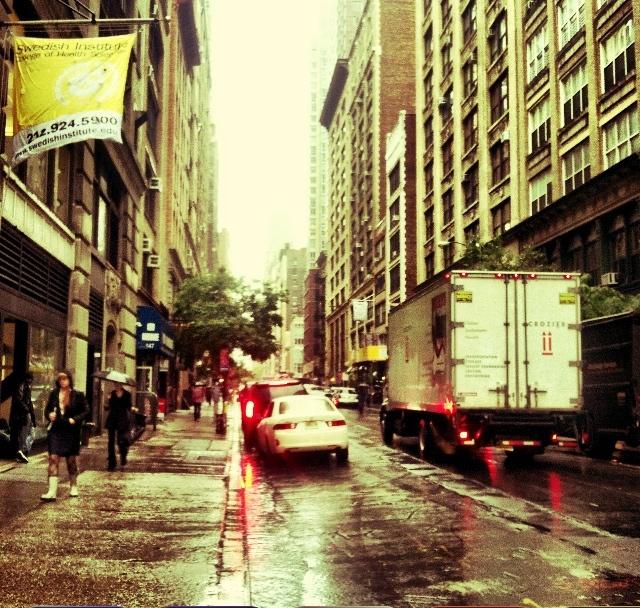What is the telephone number on the banner?
Write a very short answer. 212.924.5900. Are the cars going up or down the street?
Keep it brief. Up. Are there buildings on either side of the road?
Give a very brief answer. Yes. What type of tree is growing on the sidewalk?
Keep it brief. Oak. 